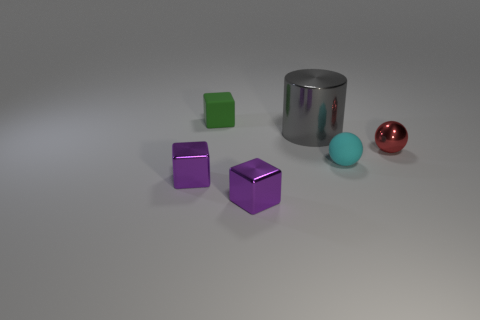Subtract all cyan spheres. How many purple blocks are left? 2 Subtract all shiny blocks. How many blocks are left? 1 Add 1 small green matte cubes. How many objects exist? 7 Subtract all cylinders. How many objects are left? 5 Subtract all red objects. Subtract all small metal spheres. How many objects are left? 4 Add 4 red metal objects. How many red metal objects are left? 5 Add 3 metallic things. How many metallic things exist? 7 Subtract 0 cyan cylinders. How many objects are left? 6 